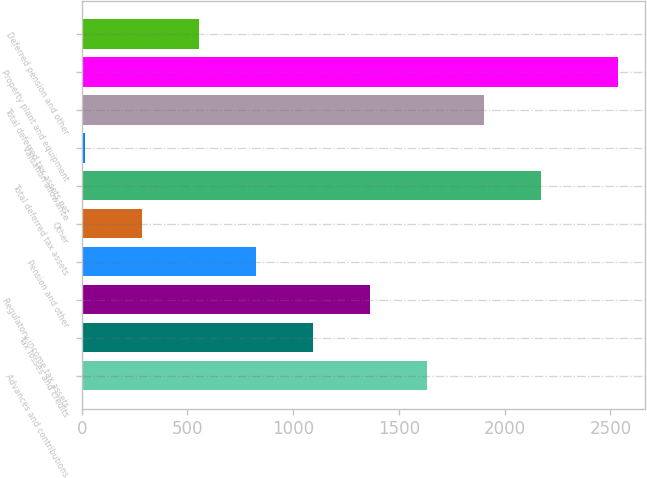<chart> <loc_0><loc_0><loc_500><loc_500><bar_chart><fcel>Advances and contributions<fcel>Tax losses and credits<fcel>Regulatory income tax assets<fcel>Pension and other<fcel>Other<fcel>Total deferred tax assets<fcel>Valuation allowance<fcel>Total deferred tax assets net<fcel>Property plant and equipment<fcel>Deferred pension and other<nl><fcel>1632.2<fcel>1092.8<fcel>1362.5<fcel>823.1<fcel>283.7<fcel>2171.6<fcel>14<fcel>1901.9<fcel>2537<fcel>553.4<nl></chart> 